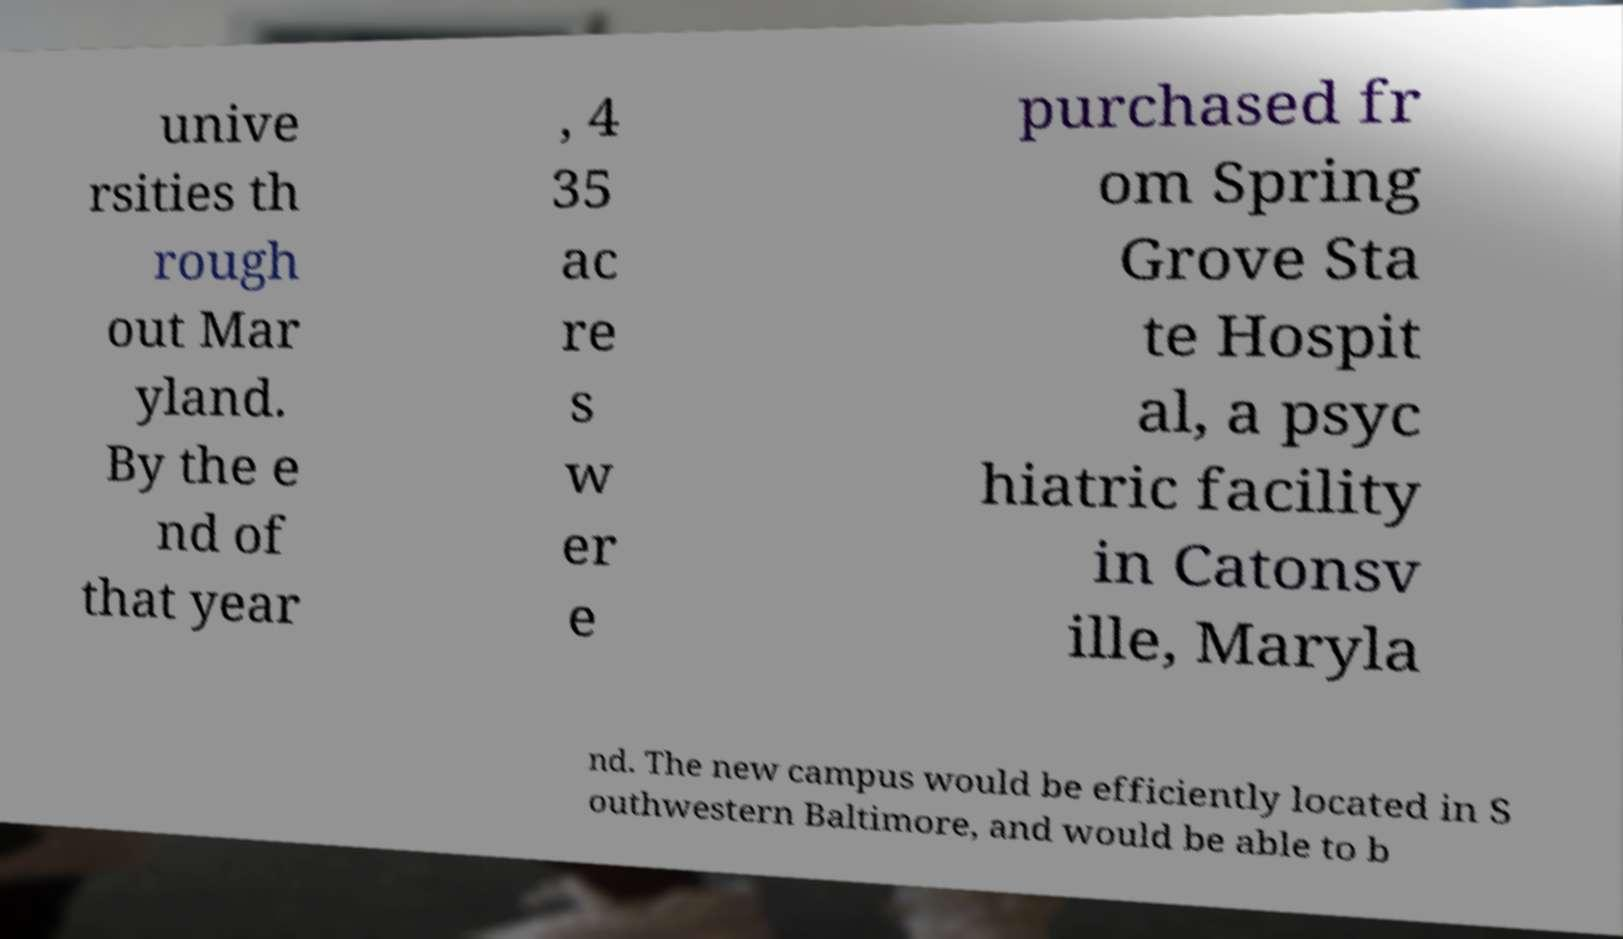Please identify and transcribe the text found in this image. unive rsities th rough out Mar yland. By the e nd of that year , 4 35 ac re s w er e purchased fr om Spring Grove Sta te Hospit al, a psyc hiatric facility in Catonsv ille, Maryla nd. The new campus would be efficiently located in S outhwestern Baltimore, and would be able to b 